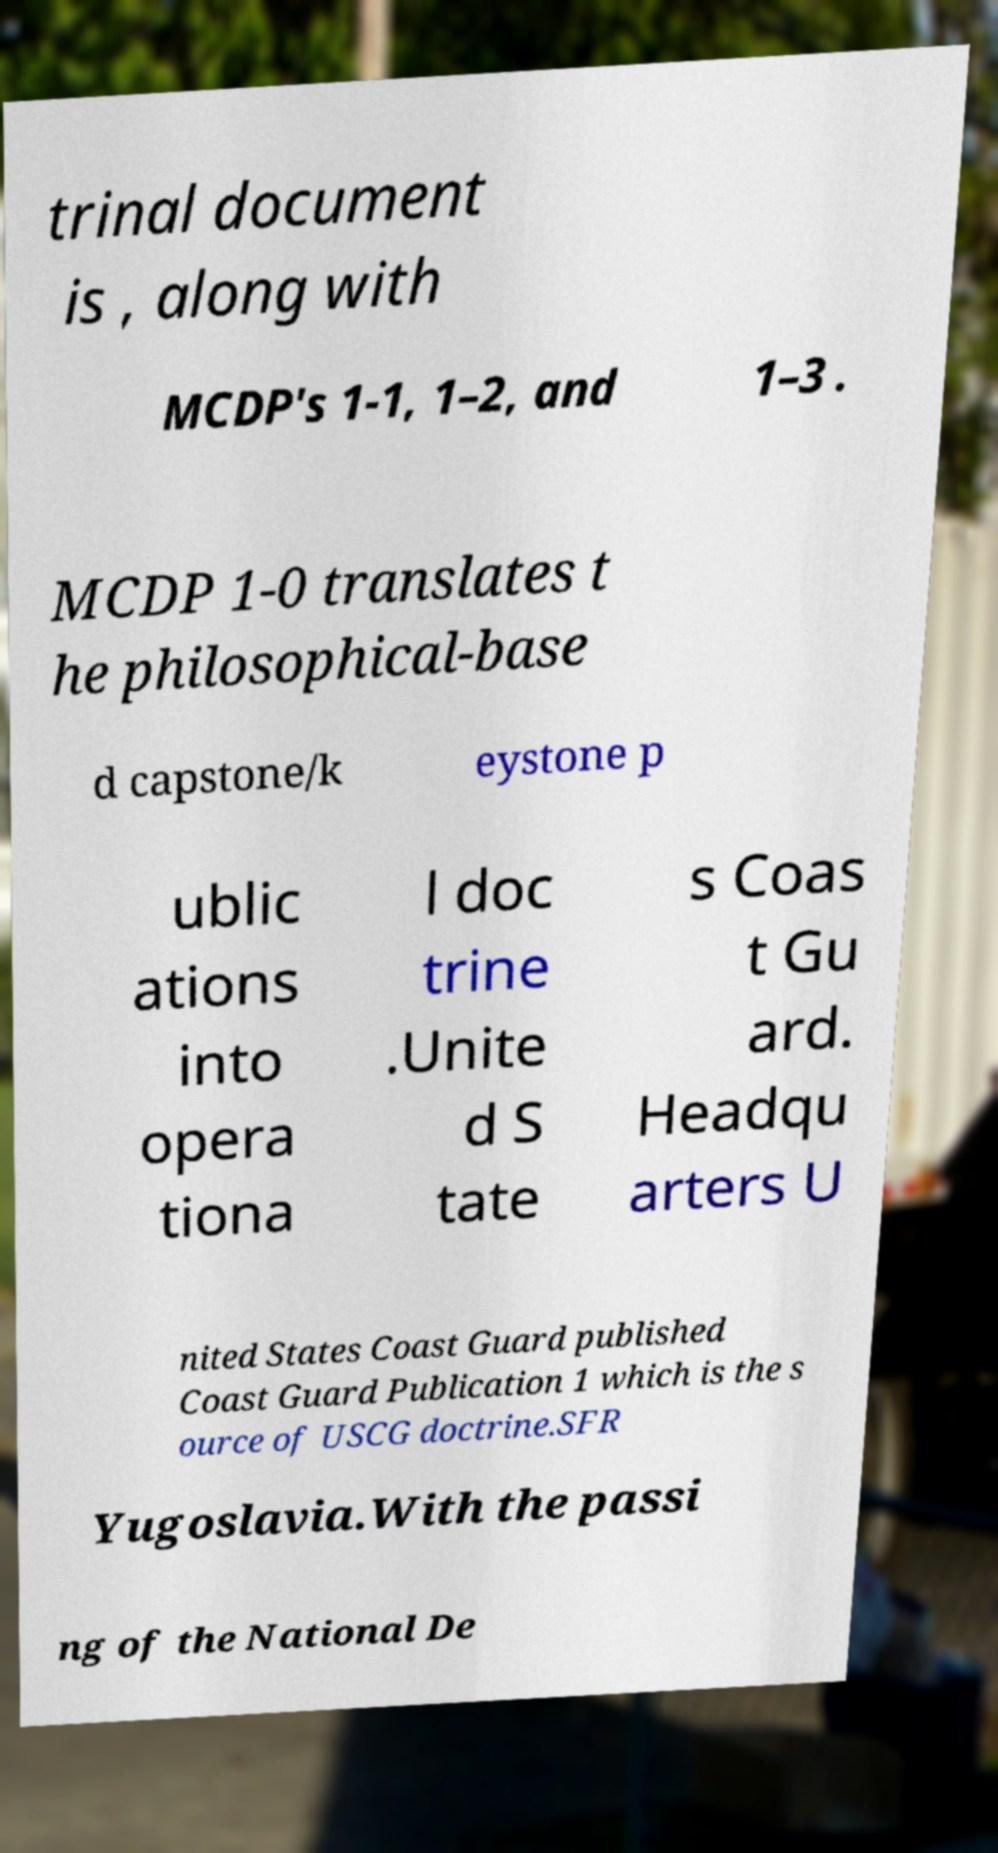For documentation purposes, I need the text within this image transcribed. Could you provide that? trinal document is , along with MCDP's 1-1, 1–2, and 1–3 . MCDP 1-0 translates t he philosophical-base d capstone/k eystone p ublic ations into opera tiona l doc trine .Unite d S tate s Coas t Gu ard. Headqu arters U nited States Coast Guard published Coast Guard Publication 1 which is the s ource of USCG doctrine.SFR Yugoslavia.With the passi ng of the National De 